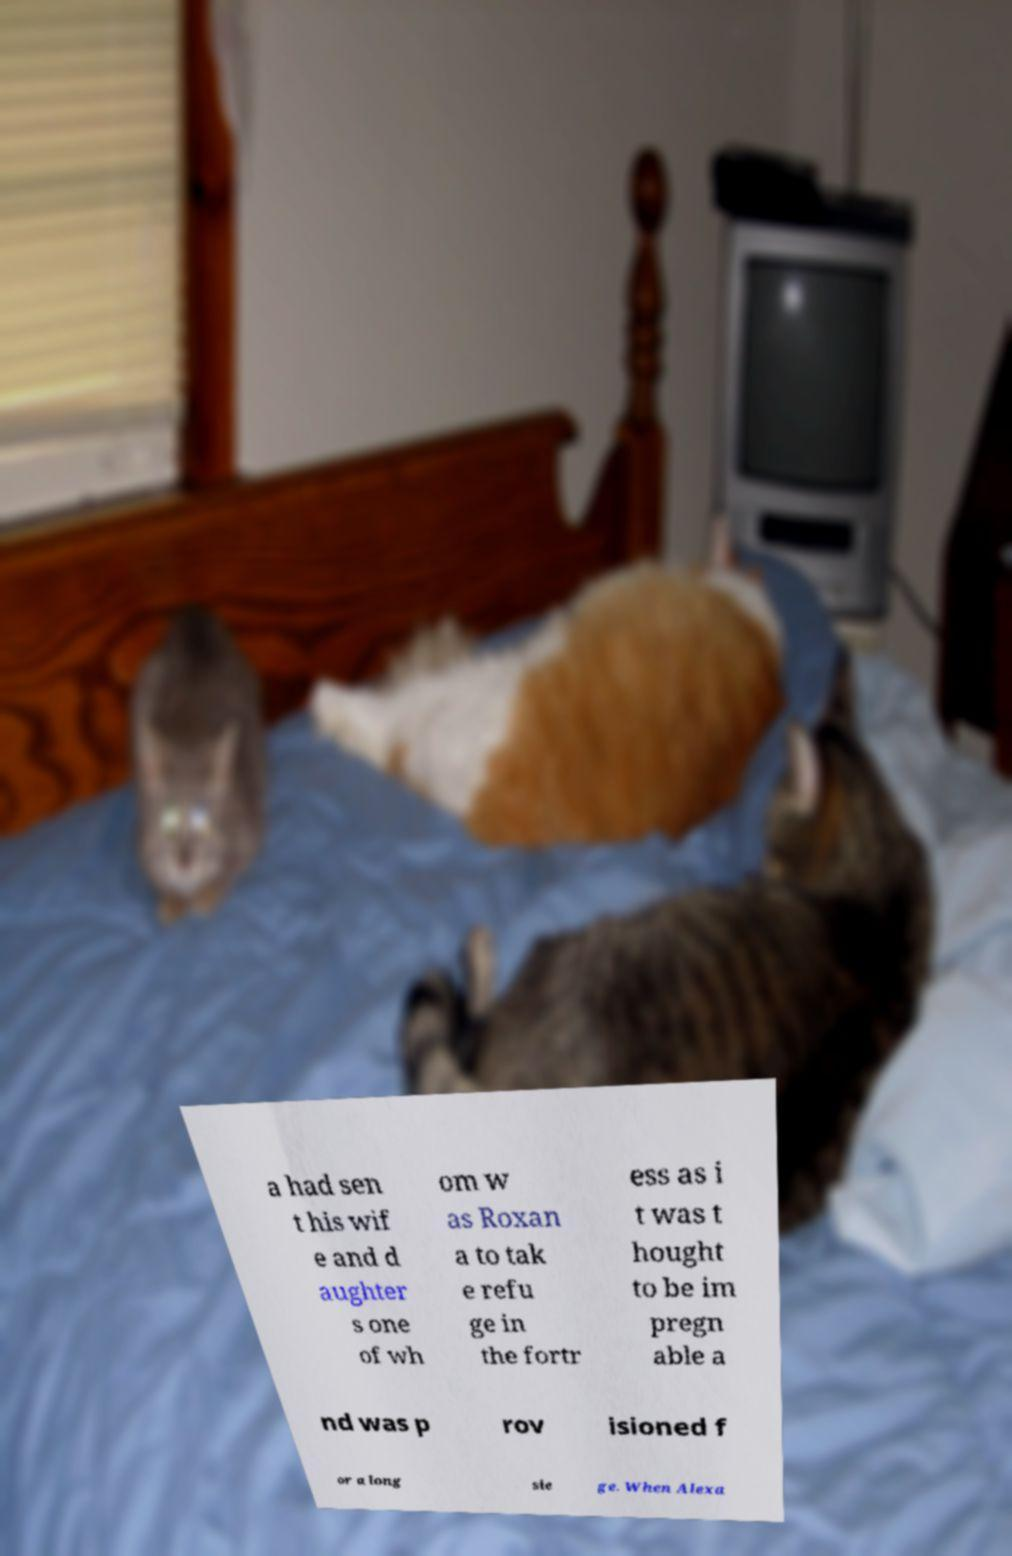Could you assist in decoding the text presented in this image and type it out clearly? a had sen t his wif e and d aughter s one of wh om w as Roxan a to tak e refu ge in the fortr ess as i t was t hought to be im pregn able a nd was p rov isioned f or a long sie ge. When Alexa 